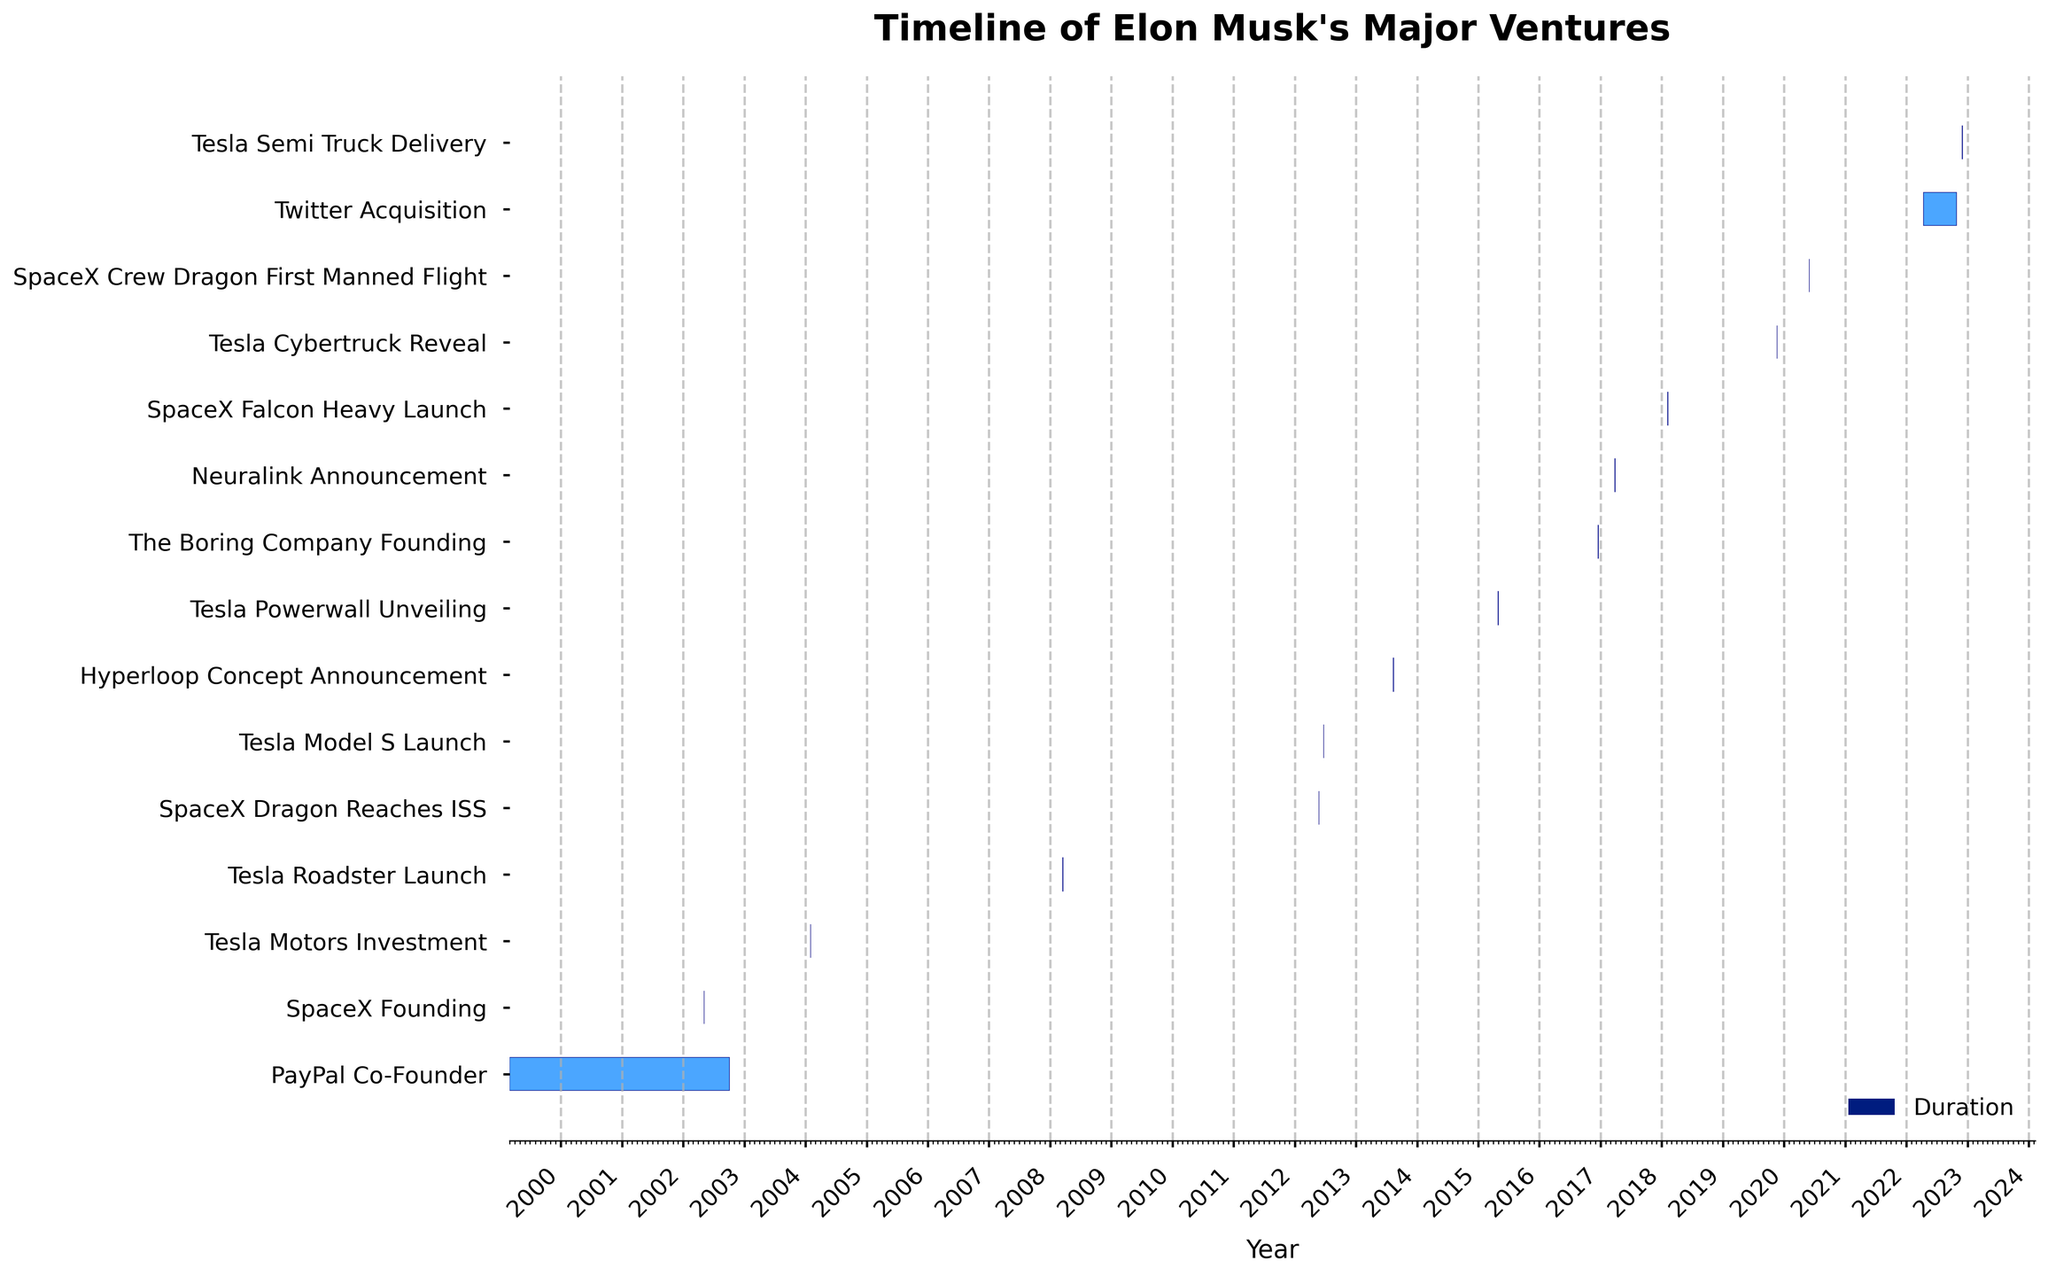When was the founding date of SpaceX? The figure shows a bar for SpaceX Founding that starts and ends on the same date. According to the timeline, this date is located at the beginning of 2002.
Answer: May 6, 2002 What is the duration between the start and end of Elon Musk's involvement with PayPal? The Gantt chart shows a bar labeled "PayPal Co-Founder" with the start date in early 1999 and the end date in late 2002. The difference in years is approximately 3 years and 7 months.
Answer: 3 years and 7 months Which major event in Tesla occurred in 2015? The Gantt chart shows that the Tesla Powerwall Unveiling is the only event associated with Tesla in 2015. This bar is shown in the middle of the year.
Answer: Tesla Powerwall Unveiling Which event came first, Tesla Roadster Launch or SpaceX Dragon Reaches ISS? The Gantt chart positions the Tesla Roadster Launch in 2008 and the SpaceX Dragon Reaches ISS in 2012. Comparing these positions, the Tesla Roadster Launch came first.
Answer: Tesla Roadster Launch What is the interval between the unveiling of Tesla Cybertruck and the first manned flight of SpaceX Crew Dragon? According to the Gantt chart, Tesla Cybertruck Reveal is in late 2019 and SpaceX Crew Dragon First Manned Flight is in mid-2020. The time interval between these two events is about 6 months.
Answer: 6 months Which product launch is the latest according to the timeline? The chart shows that the Tesla Semi Truck Delivery is the latest event, occurring toward the end of 2022.
Answer: Tesla Semi Truck Delivery How many years apart are the SpaceX Falcon Heavy Launch and the Neuralink Announcement? The Gantt chart shows that Neuralink Announcement happened in early 2017, and SpaceX Falcon Heavy Launch occurred in early 2018. The difference between these events is roughly 1 year.
Answer: 1 year How many different ventures are listed in the chart for Tesla? The Gantt chart includes "Tesla Motors Investment," "Tesla Roadster Launch," "Tesla Model S Launch," "Tesla Powerwall Unveiling," "Tesla Cybertruck Reveal," and "Tesla Semi Truck Delivery." Counting these, we find 6 different ventures.
Answer: 6 In what month and year was Neuralink first announced? According to the Gantt chart, the Neuralink Announcement is shown in early 2017. The exact date marked is March 27, 2017.
Answer: March 27, 2017 